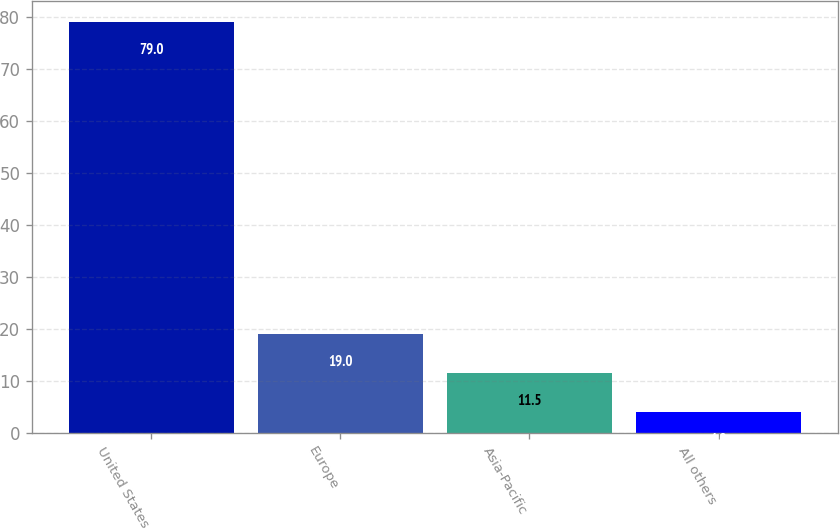<chart> <loc_0><loc_0><loc_500><loc_500><bar_chart><fcel>United States<fcel>Europe<fcel>Asia-Pacific<fcel>All others<nl><fcel>79<fcel>19<fcel>11.5<fcel>4<nl></chart> 